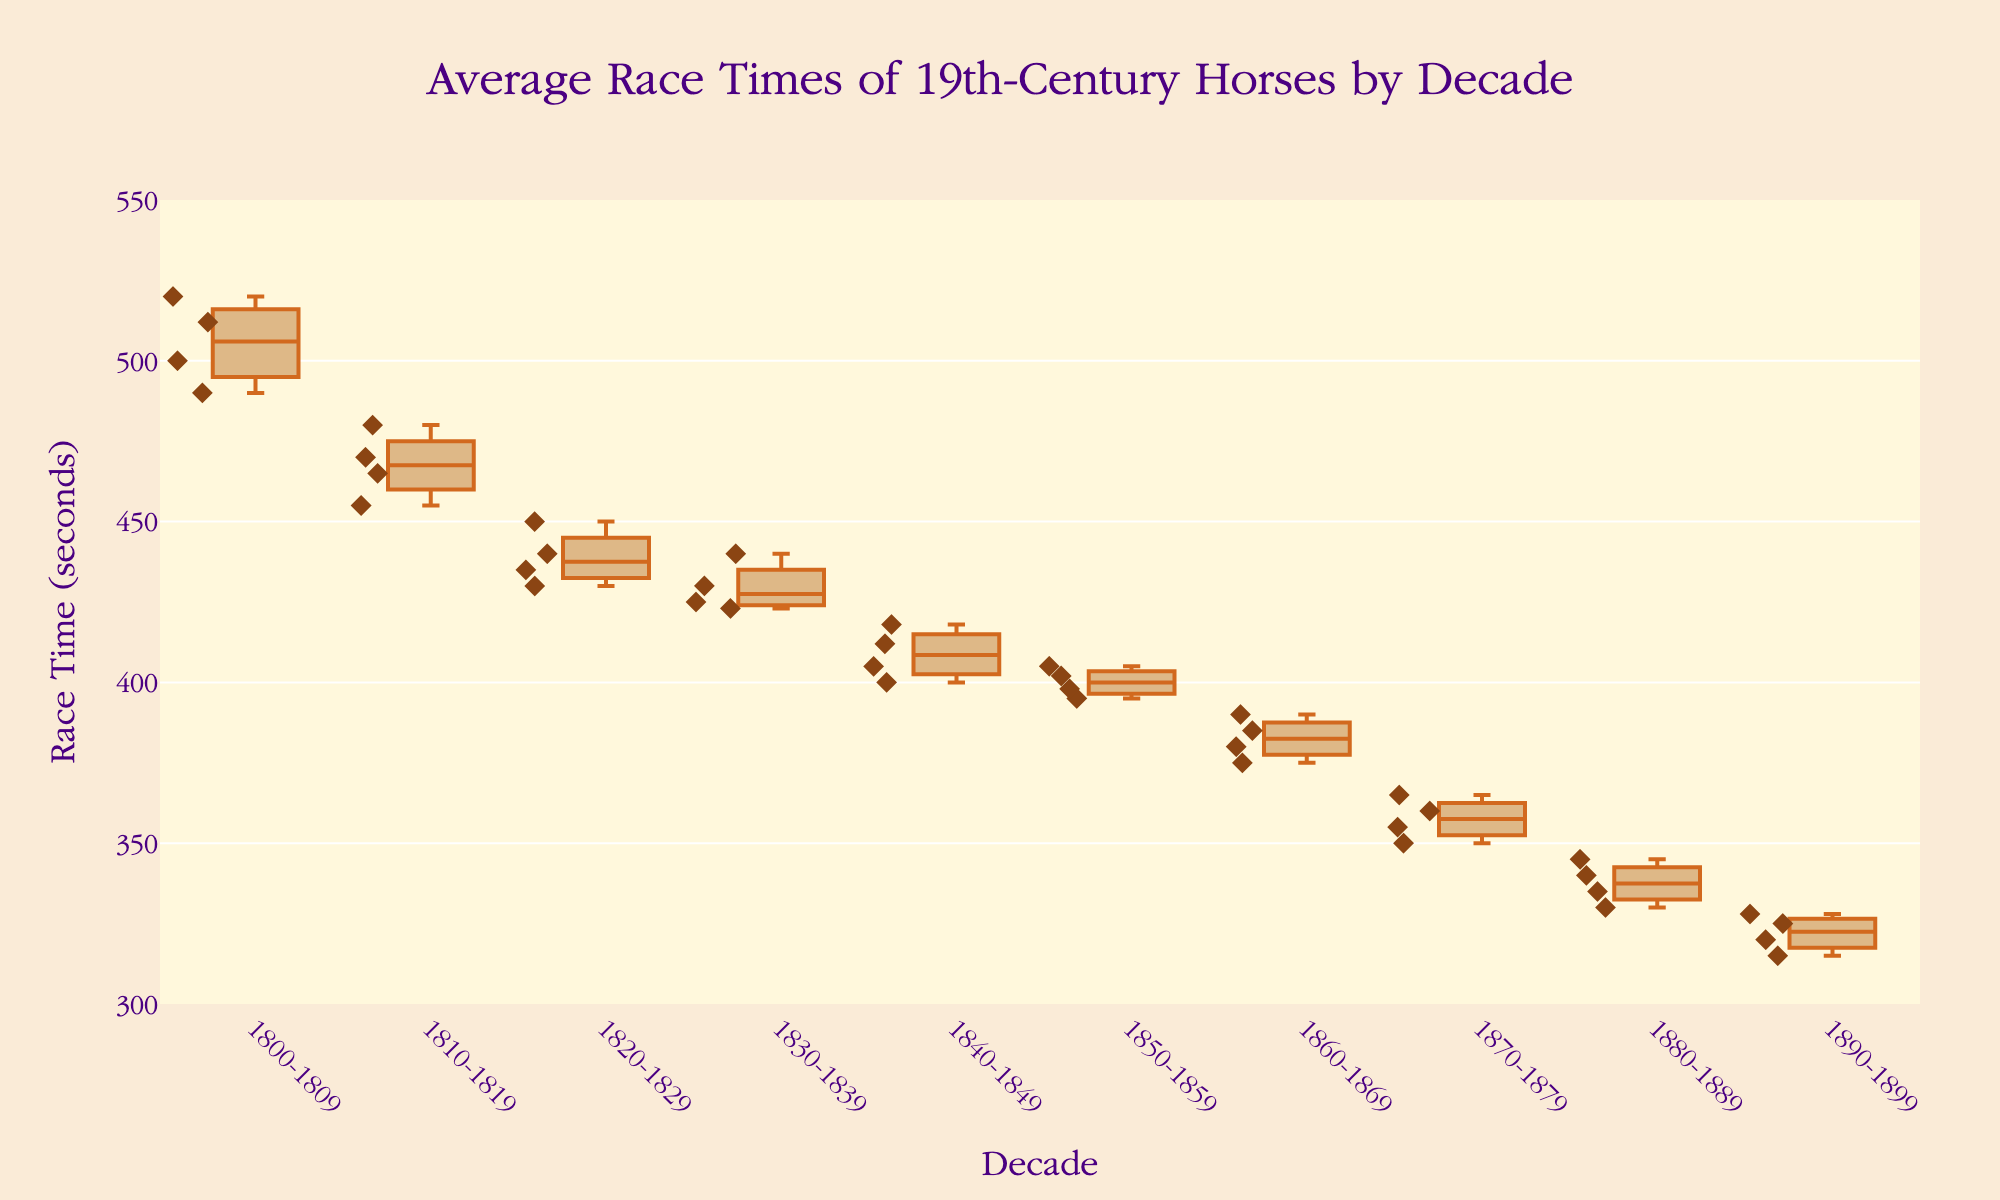what is the title of the plot? The title of the plot is located at the top center, displaying the main subject of the figure. From the given code, we know the title is set explicitly.
Answer: Average Race Times of 19th-Century Horses by Decade Which decade shows the fastest median race time? The median race time is represented by the line inside each box. The box with the line closest to the bottom represents the fastest median race time.
Answer: 1890-1899 How many horse race times are displayed in the plot for the decade 1820-1829? Each scatter point represents a horse race time within a decade. Counting the points corresponding to the 1820-1829 decade will give the answer.
Answer: 4 What is the range of race times in the 1870-1879 decade? The range is determined by the minimum and maximum values in the box plot for the 1870-1879 decade. The bottom whisker shows the minimum, and the top whisker shows the maximum race time.
Answer: 350 to 365 seconds Which horse had the slowest race time overall? The scatter point at the highest position in the entire plot represents the slowest (largest) race time across all decades.
Answer: Scud Which decade shows the smallest interquartile range (IQR) for race times? The IQR is the distance between the bottom (Q1) and top (Q3) of each box in the box plot. The decade with the smallest box height has the smallest IQR.
Answer: 1870-1879 How does the average race time trend over the decades? By observing the median line in each box plot across the decades, we can derive the trend. If the median lines generally move downward, the average trend is decreasing.
Answer: Decreasing In the 1830-1839 decade, what is the race time for Hermit? Locate the scatter points in the 1830-1839 box plot and identify the point labeled "Hermit."
Answer: 423 seconds How many unique horses are depicted in the plot for the 1800-1809 decade? Count the scatter points for the 1800-1809 decade. Each point represents a unique horse.
Answer: 4 Which decade had the most consistent race times? The consistency of race times can be measured by the smallest spread of the box plot, indicated by the IQR and the overall height of the whiskers. The decade with the smallest overall height is the most consistent.
Answer: 1870-1879 